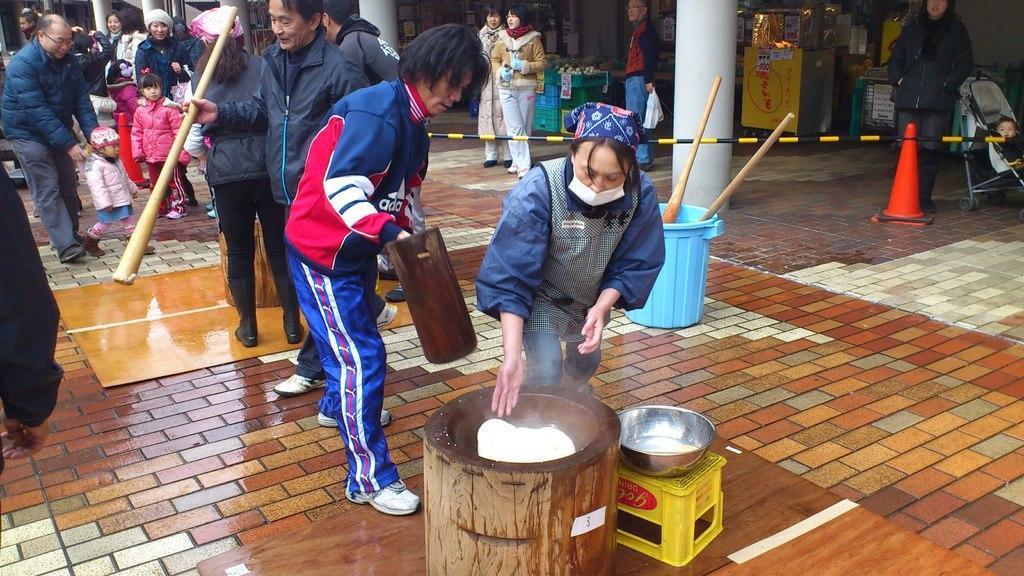Describe this image in one or two sentences. As we can see in the image there are few people here and there, buildings, traffic cone, bowl, stool and a drum. 